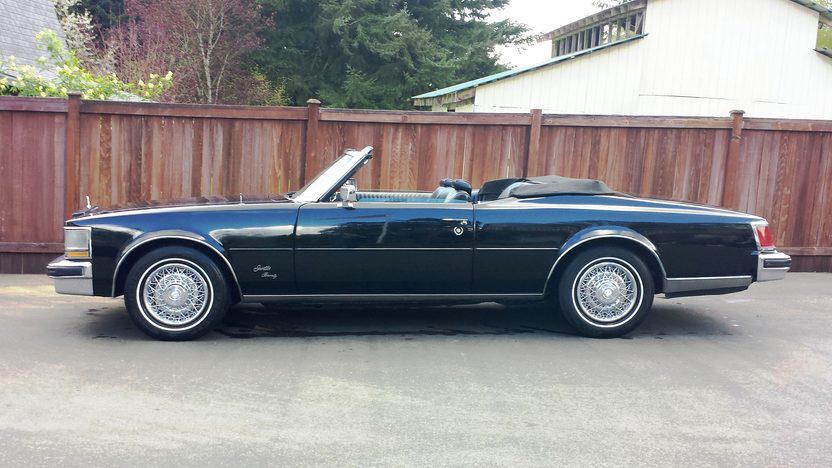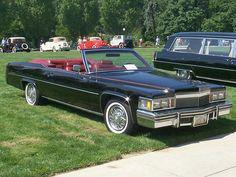The first image is the image on the left, the second image is the image on the right. Evaluate the accuracy of this statement regarding the images: "1 car has it's convertible top up.". Is it true? Answer yes or no. No. The first image is the image on the left, the second image is the image on the right. For the images shown, is this caption "In one image exactly one convertible car is on the grass." true? Answer yes or no. Yes. 